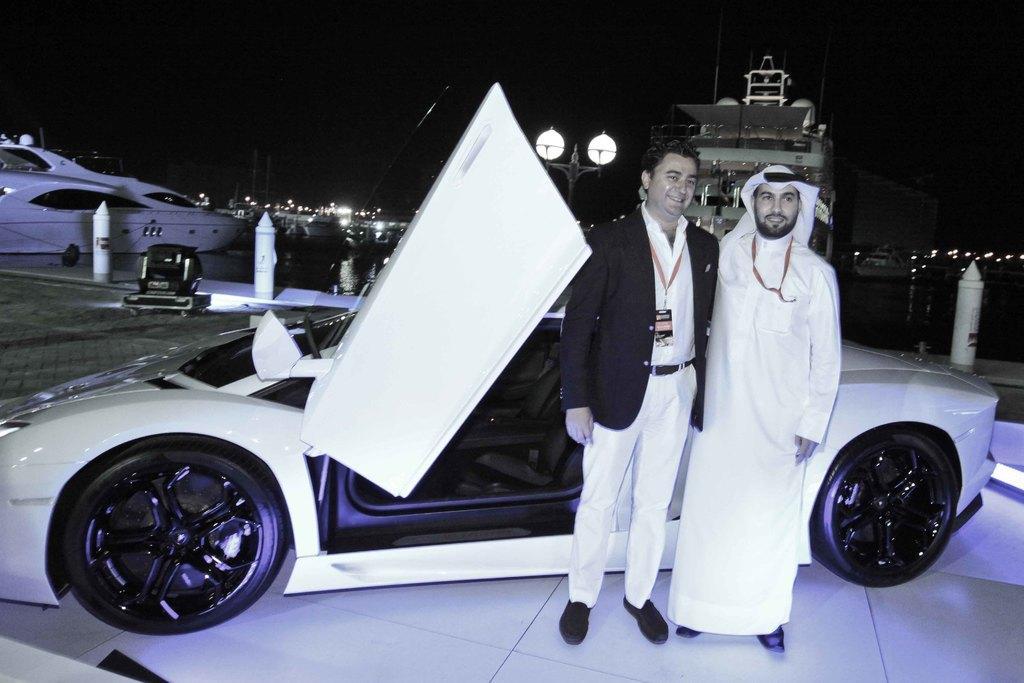Could you give a brief overview of what you see in this image? In this image we can see two persons wearing the identity cards and standing and also smiling. We can also see a car, path, barrier rods and also an object. In the background we can see the boats and also the ships on the surface of the water. We can also see the lights. At the bottom we can see the surface. 